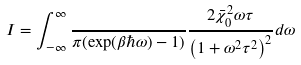<formula> <loc_0><loc_0><loc_500><loc_500>I = \int _ { - \infty } ^ { \infty } \frac { } { \pi ( \exp ( \beta \hbar { \omega } ) - 1 ) } \frac { 2 \bar { \chi } _ { 0 } ^ { 2 } \omega \tau } { \left ( 1 + \omega ^ { 2 } \tau ^ { 2 } \right ) ^ { 2 } } d \omega</formula> 